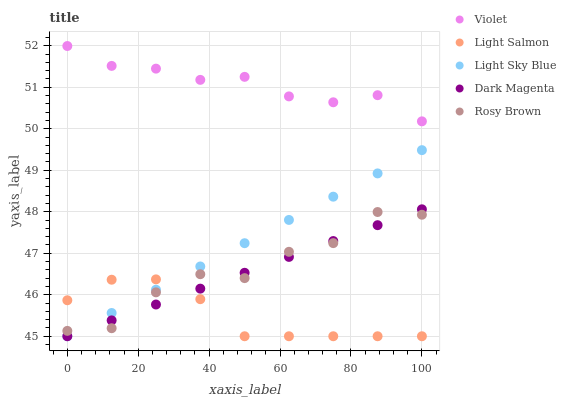Does Light Salmon have the minimum area under the curve?
Answer yes or no. Yes. Does Violet have the maximum area under the curve?
Answer yes or no. Yes. Does Light Sky Blue have the minimum area under the curve?
Answer yes or no. No. Does Light Sky Blue have the maximum area under the curve?
Answer yes or no. No. Is Dark Magenta the smoothest?
Answer yes or no. Yes. Is Rosy Brown the roughest?
Answer yes or no. Yes. Is Light Sky Blue the smoothest?
Answer yes or no. No. Is Light Sky Blue the roughest?
Answer yes or no. No. Does Light Salmon have the lowest value?
Answer yes or no. Yes. Does Rosy Brown have the lowest value?
Answer yes or no. No. Does Violet have the highest value?
Answer yes or no. Yes. Does Light Sky Blue have the highest value?
Answer yes or no. No. Is Light Sky Blue less than Violet?
Answer yes or no. Yes. Is Violet greater than Light Salmon?
Answer yes or no. Yes. Does Rosy Brown intersect Light Sky Blue?
Answer yes or no. Yes. Is Rosy Brown less than Light Sky Blue?
Answer yes or no. No. Is Rosy Brown greater than Light Sky Blue?
Answer yes or no. No. Does Light Sky Blue intersect Violet?
Answer yes or no. No. 